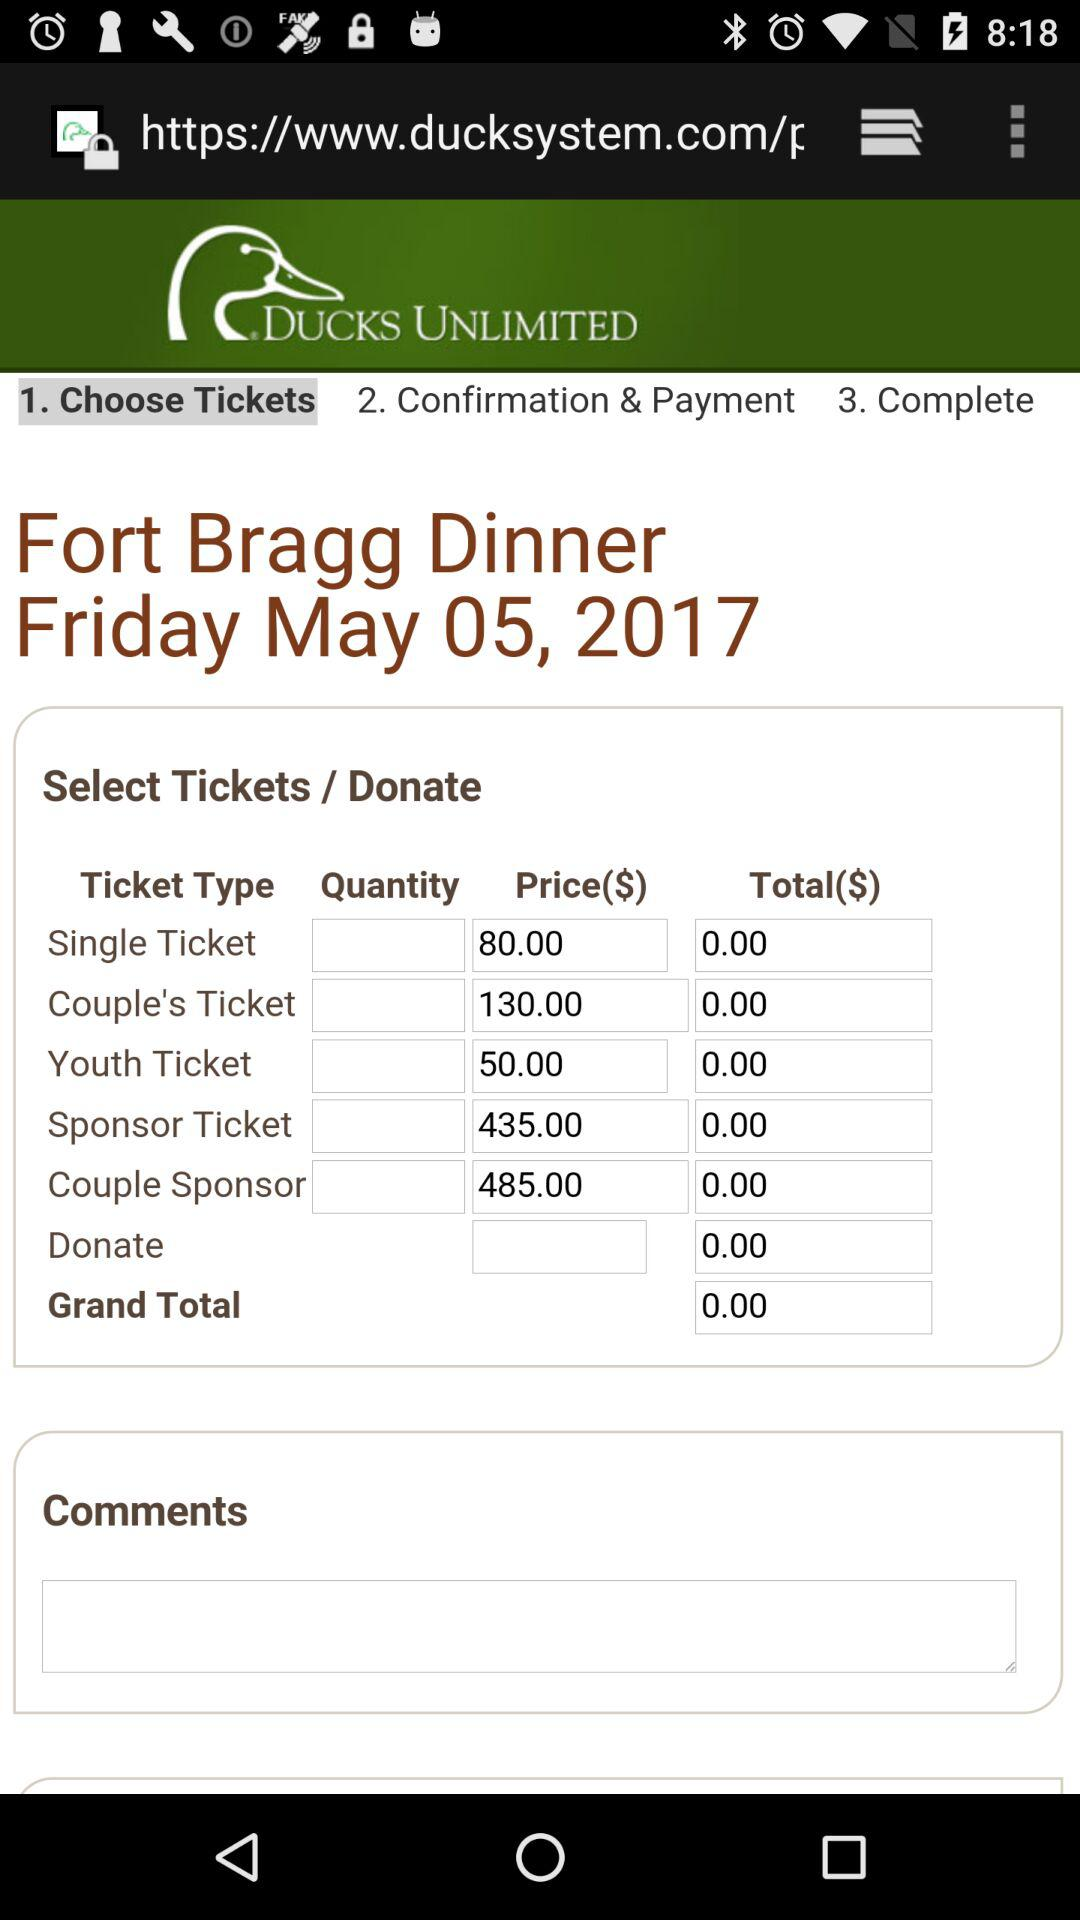Which Tab is been selected?
When the provided information is insufficient, respond with <no answer>. <no answer> 